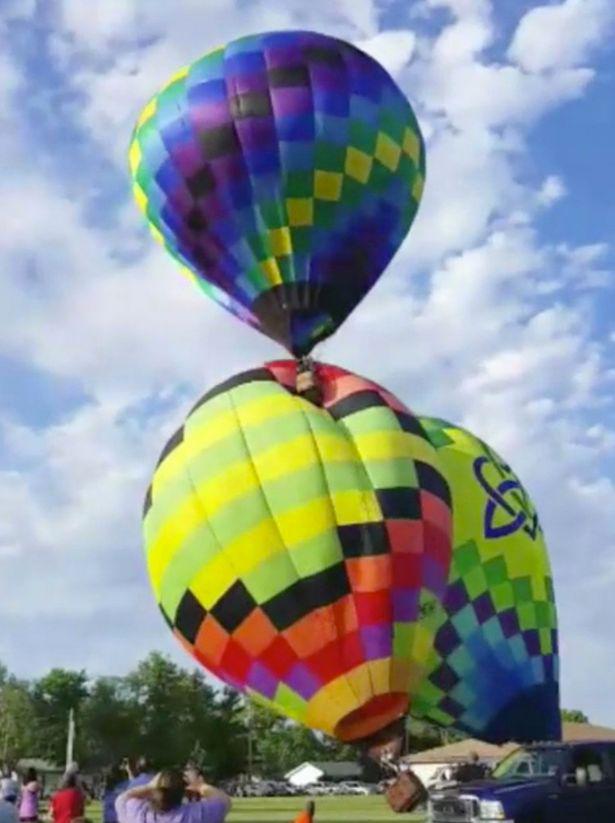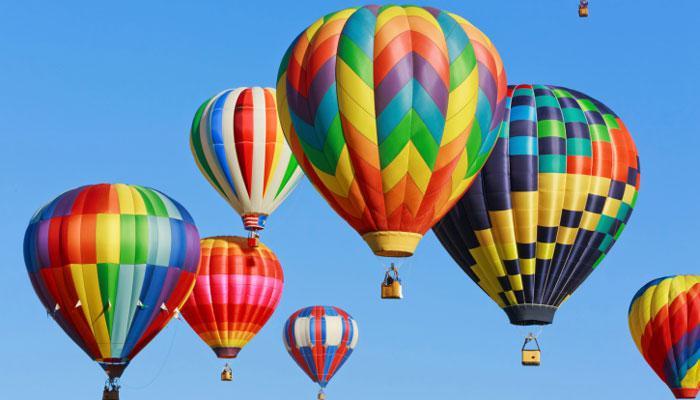The first image is the image on the left, the second image is the image on the right. For the images displayed, is the sentence "Only one image in the pair contains a single balloon." factually correct? Answer yes or no. No. The first image is the image on the left, the second image is the image on the right. Analyze the images presented: Is the assertion "One image contains at least 7 hot air balloons." valid? Answer yes or no. Yes. 